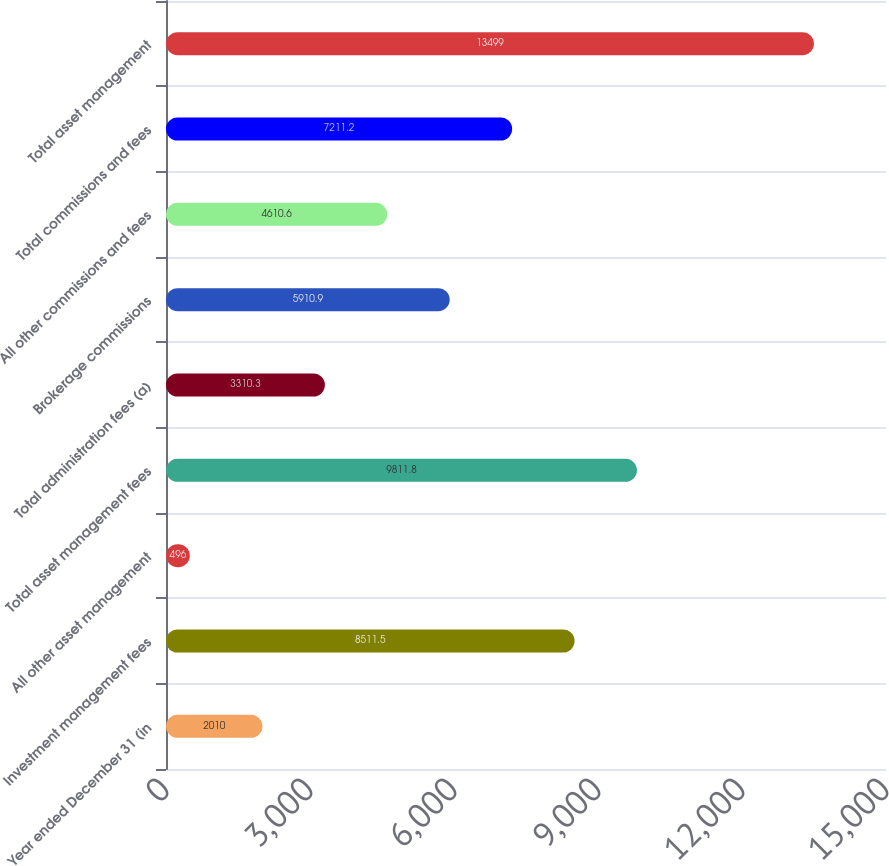<chart> <loc_0><loc_0><loc_500><loc_500><bar_chart><fcel>Year ended December 31 (in<fcel>Investment management fees<fcel>All other asset management<fcel>Total asset management fees<fcel>Total administration fees (a)<fcel>Brokerage commissions<fcel>All other commissions and fees<fcel>Total commissions and fees<fcel>Total asset management<nl><fcel>2010<fcel>8511.5<fcel>496<fcel>9811.8<fcel>3310.3<fcel>5910.9<fcel>4610.6<fcel>7211.2<fcel>13499<nl></chart> 